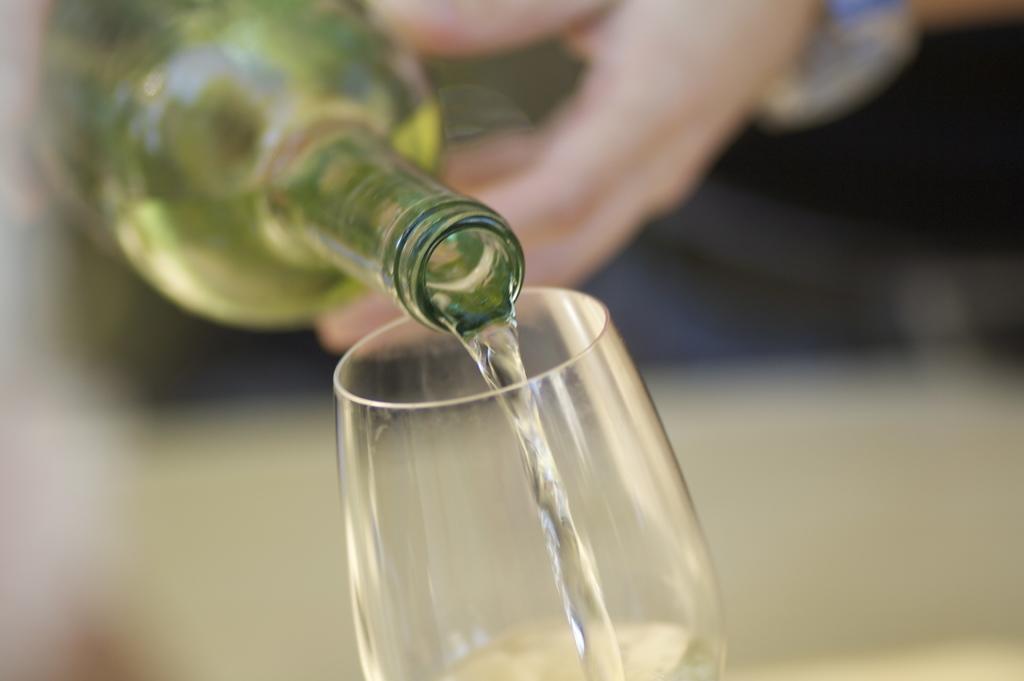Can you describe this image briefly? In this picture we can see we can see a person who is pouring water from the bottle into glass. 